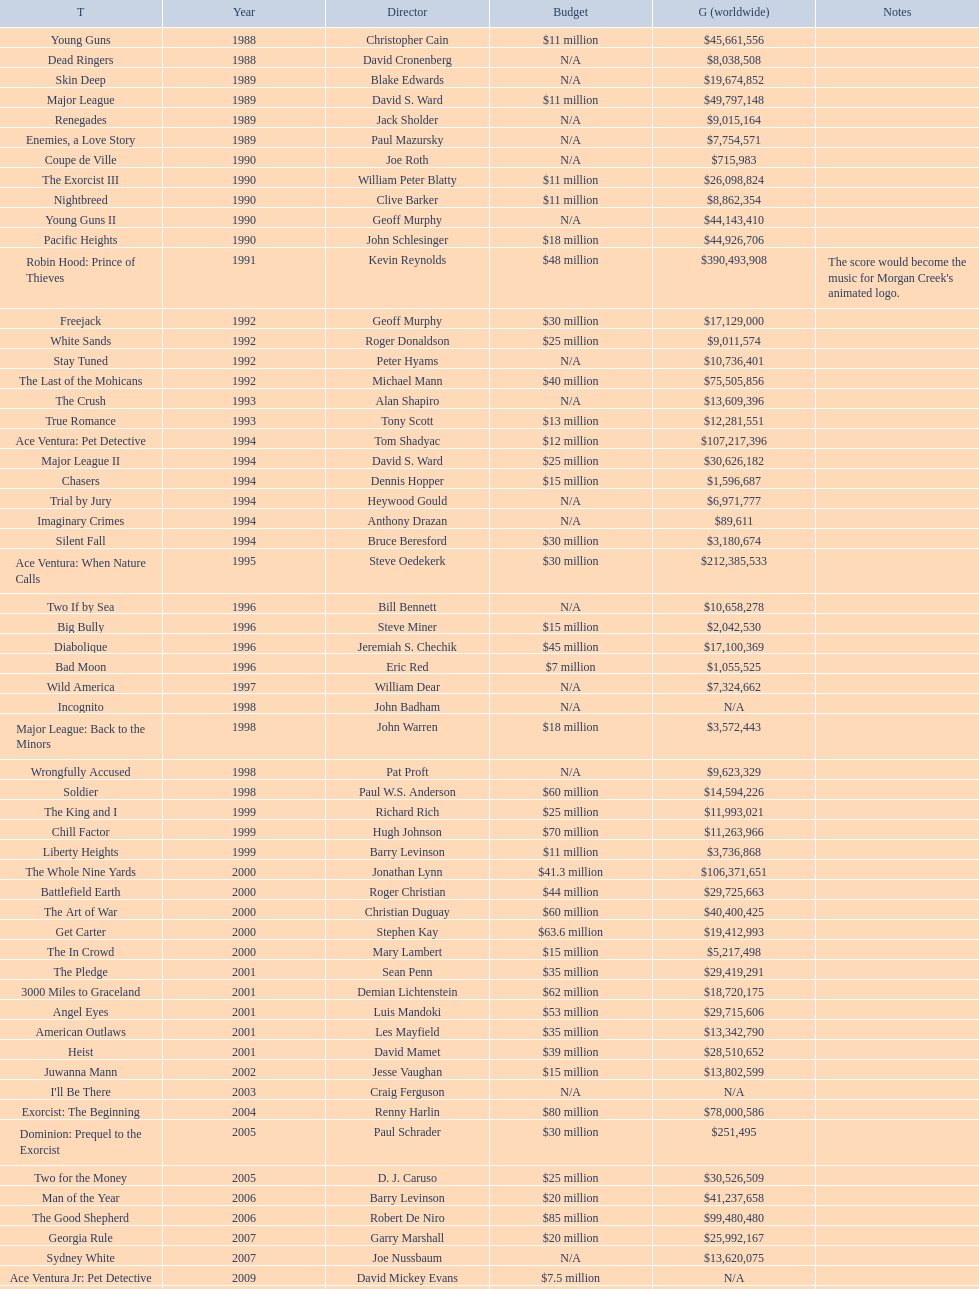Was the budget for young guns more or less than freejack's budget? Less. 